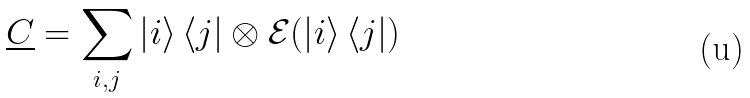<formula> <loc_0><loc_0><loc_500><loc_500>\underline { C } = \underset { i , j } { \sum } \left | i \right \rangle \left \langle j \right | \otimes \mathcal { E } ( \left | i \right \rangle \left \langle j \right | )</formula> 